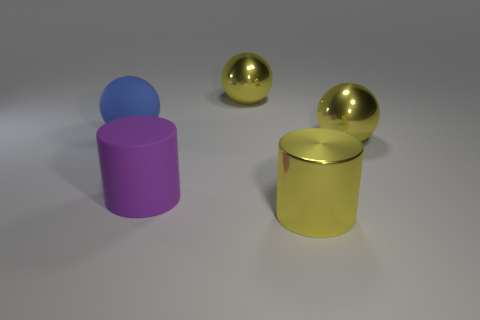Add 1 big brown metallic objects. How many objects exist? 6 Subtract all cylinders. How many objects are left? 3 Add 1 shiny cylinders. How many shiny cylinders exist? 2 Subtract 0 purple cubes. How many objects are left? 5 Subtract all brown metal cylinders. Subtract all large purple things. How many objects are left? 4 Add 2 yellow spheres. How many yellow spheres are left? 4 